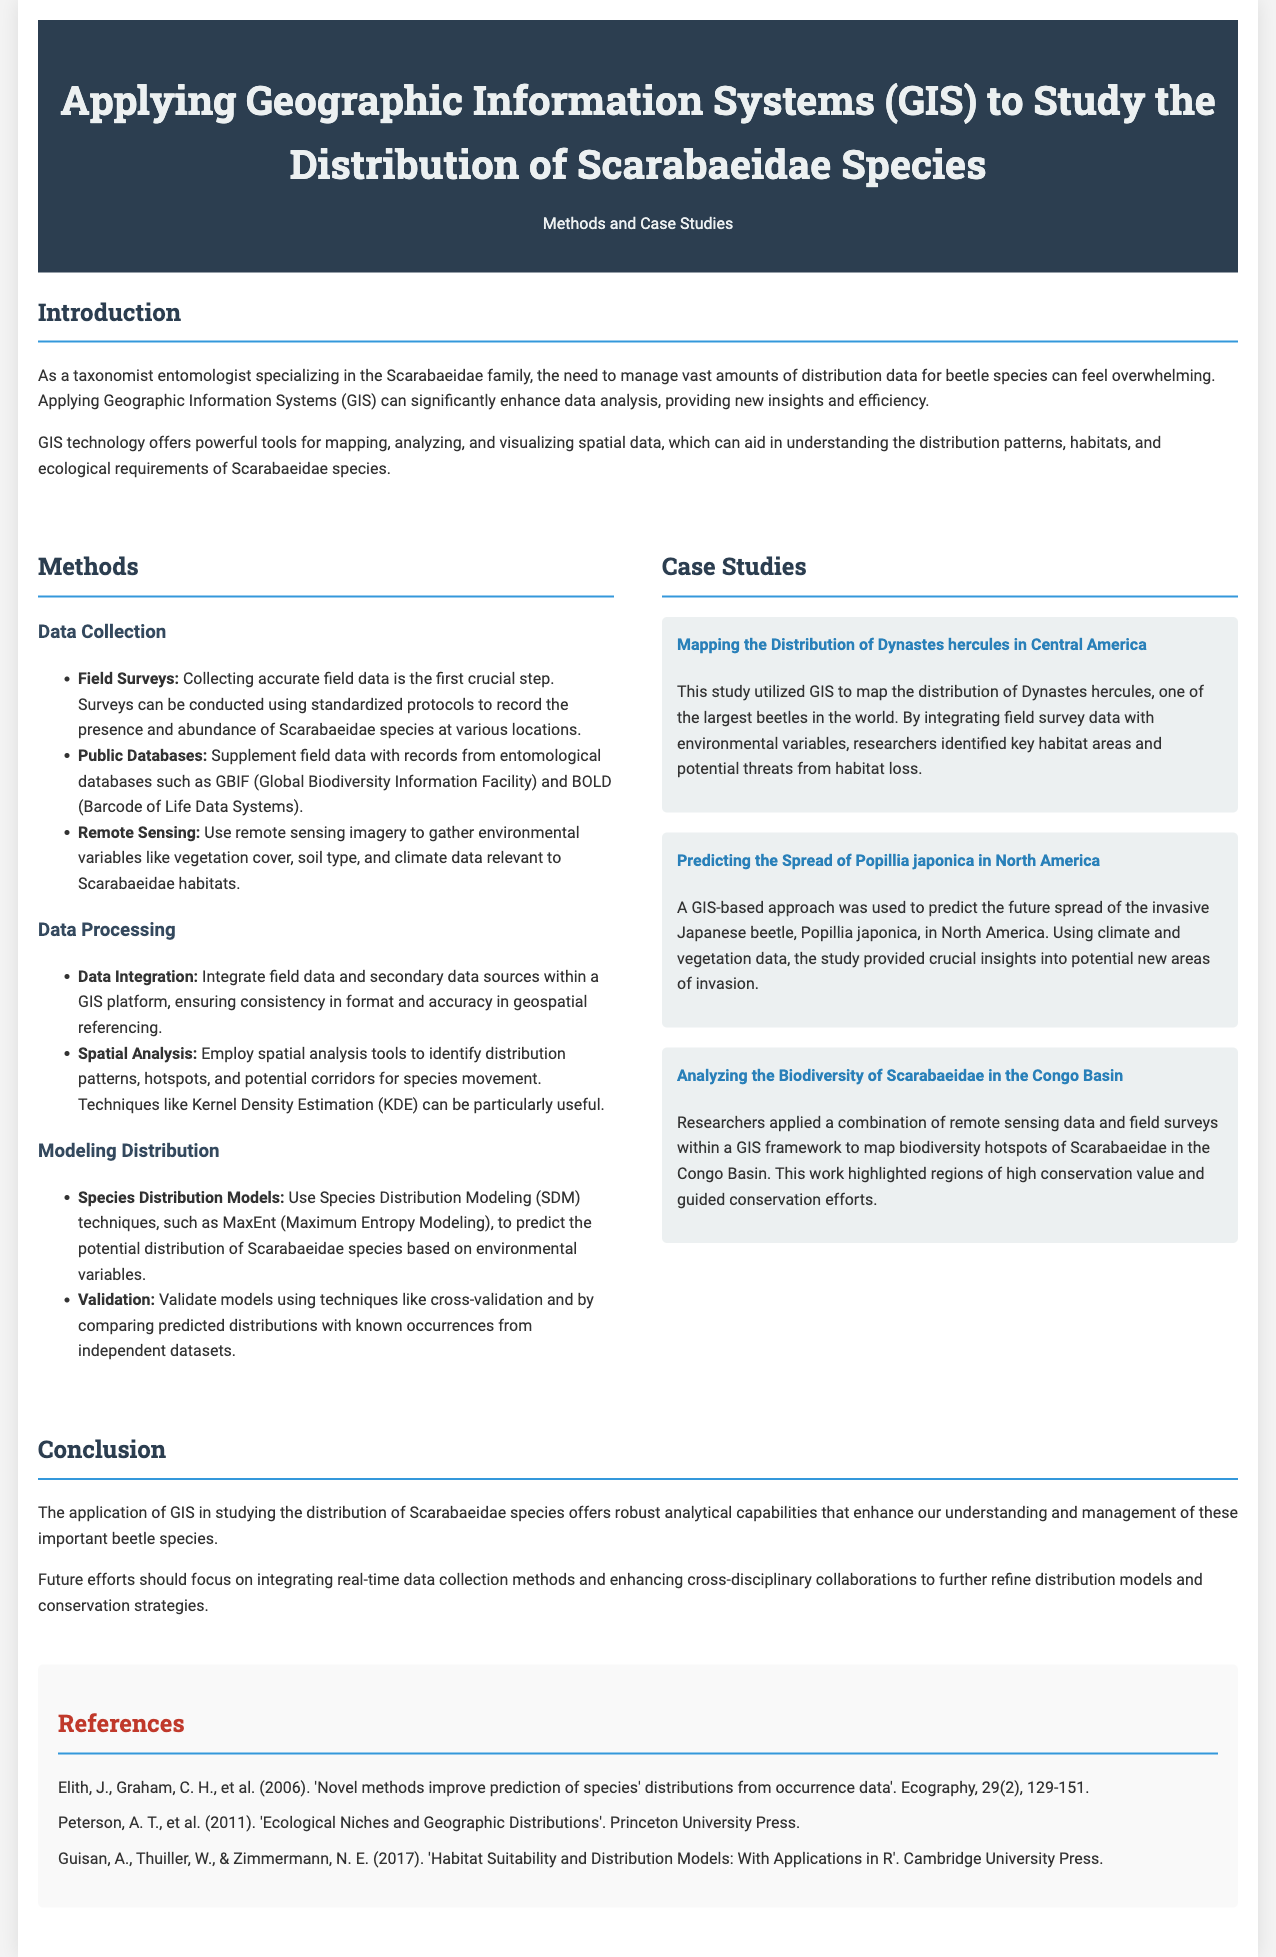What is the title of the document? The title is clearly stated at the top of the document.
Answer: Applying Geographic Information Systems (GIS) to Study the Distribution of Scarabaeidae Species What are the three data collection methods mentioned? Specific data collection methods are listed in the methods section of the document.
Answer: Field Surveys, Public Databases, Remote Sensing What is one of the case studies focused on? The case studies section highlights specific studies related to Scarabaeidae species.
Answer: Mapping the Distribution of Dynastes hercules in Central America What GIS technique is used for predicting distribution? The document mentions a specific modeling technique for predicting species distributions.
Answer: MaxEnt Which region's Scarabaeidae biodiversity is analyzed? The document specifies a geographical area related to Scarabaeidae biodiversity analysis.
Answer: Congo Basin How many references are listed in the document? The references section provides a list of sources cited throughout the document.
Answer: Three 